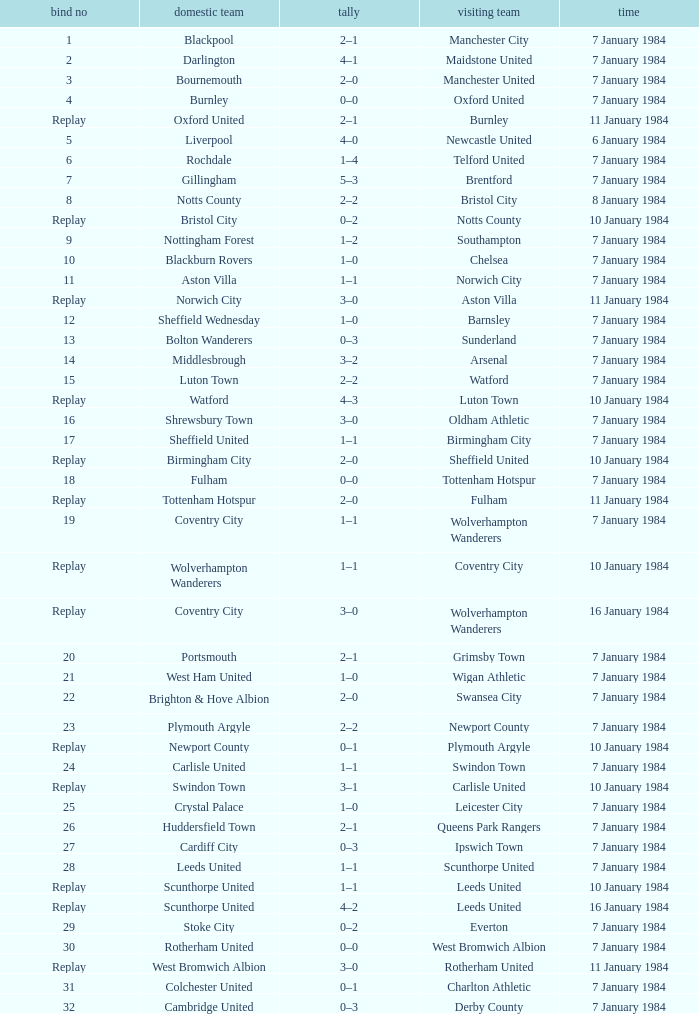Which team played as guests against sheffield united at their home ground? Birmingham City. 